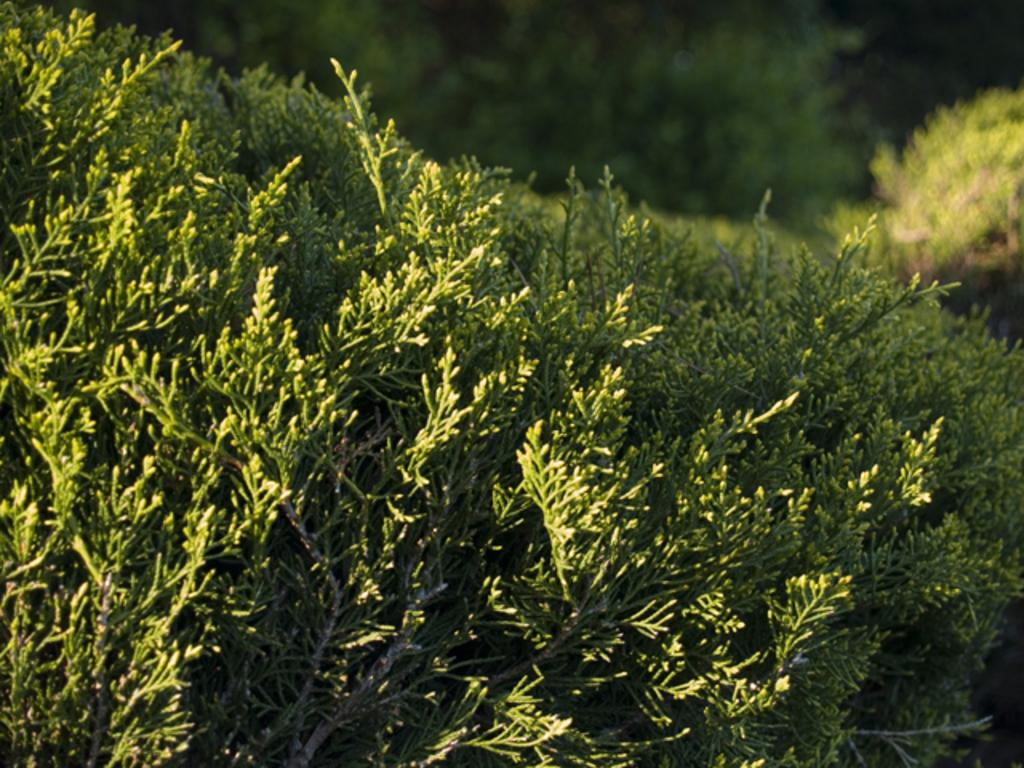What type of plants are visible in the image? There are green plants in the image. Can you describe the background of the image? The background of the image is blurry. Where is the goat in the image? There is no goat present in the image. What type of insect can be seen flying around the plants in the image? There is no insect, such as a bee, visible in the image. 